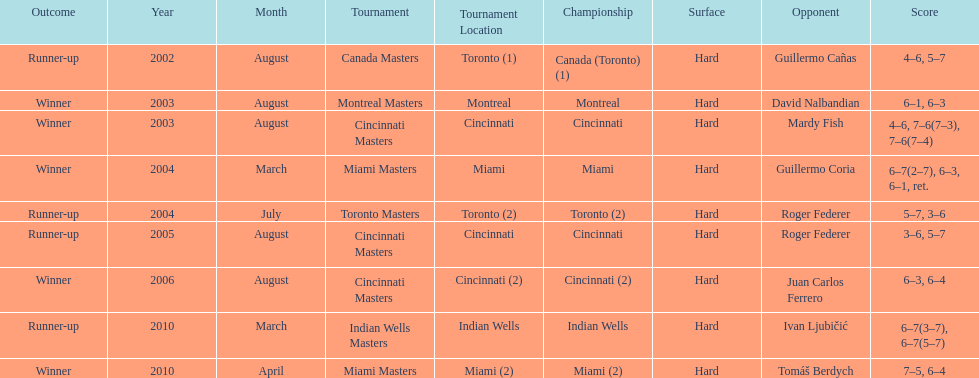What was the highest number of consecutive wins? 3. Parse the full table. {'header': ['Outcome', 'Year', 'Month', 'Tournament', 'Tournament Location', 'Championship', 'Surface', 'Opponent', 'Score'], 'rows': [['Runner-up', '2002', 'August', 'Canada Masters', 'Toronto (1)', 'Canada (Toronto) (1)', 'Hard', 'Guillermo Cañas', '4–6, 5–7'], ['Winner', '2003', 'August', 'Montreal Masters', 'Montreal', 'Montreal', 'Hard', 'David Nalbandian', '6–1, 6–3'], ['Winner', '2003', 'August', 'Cincinnati Masters', 'Cincinnati', 'Cincinnati', 'Hard', 'Mardy Fish', '4–6, 7–6(7–3), 7–6(7–4)'], ['Winner', '2004', 'March', 'Miami Masters', 'Miami', 'Miami', 'Hard', 'Guillermo Coria', '6–7(2–7), 6–3, 6–1, ret.'], ['Runner-up', '2004', 'July', 'Toronto Masters', 'Toronto (2)', 'Toronto (2)', 'Hard', 'Roger Federer', '5–7, 3–6'], ['Runner-up', '2005', 'August', 'Cincinnati Masters', 'Cincinnati', 'Cincinnati', 'Hard', 'Roger Federer', '3–6, 5–7'], ['Winner', '2006', 'August', 'Cincinnati Masters', 'Cincinnati (2)', 'Cincinnati (2)', 'Hard', 'Juan Carlos Ferrero', '6–3, 6–4'], ['Runner-up', '2010', 'March', 'Indian Wells Masters', 'Indian Wells', 'Indian Wells', 'Hard', 'Ivan Ljubičić', '6–7(3–7), 6–7(5–7)'], ['Winner', '2010', 'April', 'Miami Masters', 'Miami (2)', 'Miami (2)', 'Hard', 'Tomáš Berdych', '7–5, 6–4']]} 